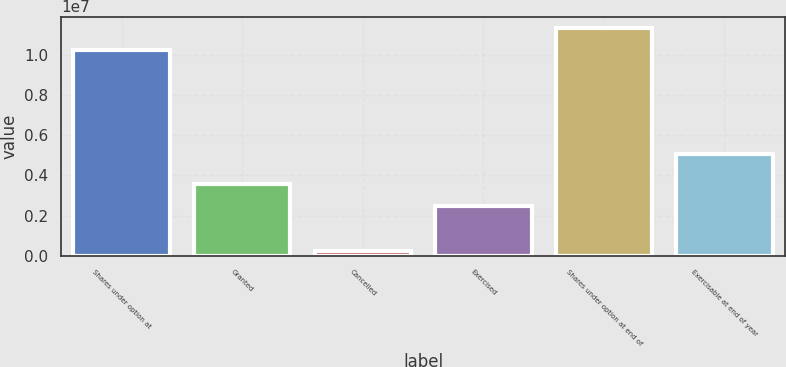<chart> <loc_0><loc_0><loc_500><loc_500><bar_chart><fcel>Shares under option at<fcel>Granted<fcel>Cancelled<fcel>Exercised<fcel>Shares under option at end of<fcel>Exercisable at end of year<nl><fcel>1.0256e+07<fcel>3.54994e+06<fcel>232488<fcel>2.46923e+06<fcel>1.13367e+07<fcel>5.06719e+06<nl></chart> 